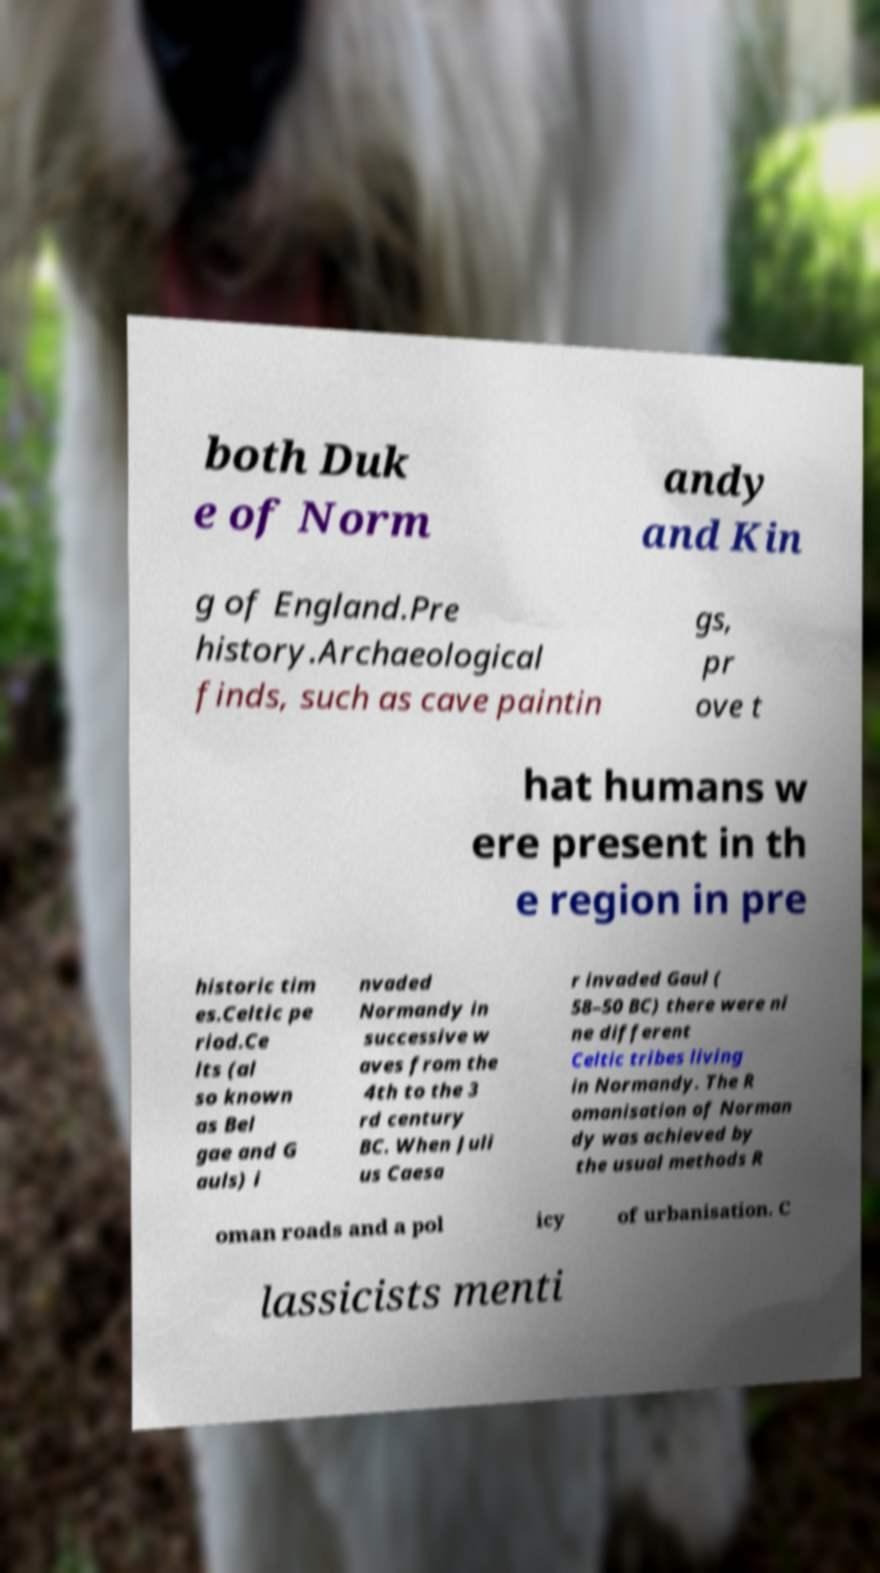There's text embedded in this image that I need extracted. Can you transcribe it verbatim? both Duk e of Norm andy and Kin g of England.Pre history.Archaeological finds, such as cave paintin gs, pr ove t hat humans w ere present in th e region in pre historic tim es.Celtic pe riod.Ce lts (al so known as Bel gae and G auls) i nvaded Normandy in successive w aves from the 4th to the 3 rd century BC. When Juli us Caesa r invaded Gaul ( 58–50 BC) there were ni ne different Celtic tribes living in Normandy. The R omanisation of Norman dy was achieved by the usual methods R oman roads and a pol icy of urbanisation. C lassicists menti 